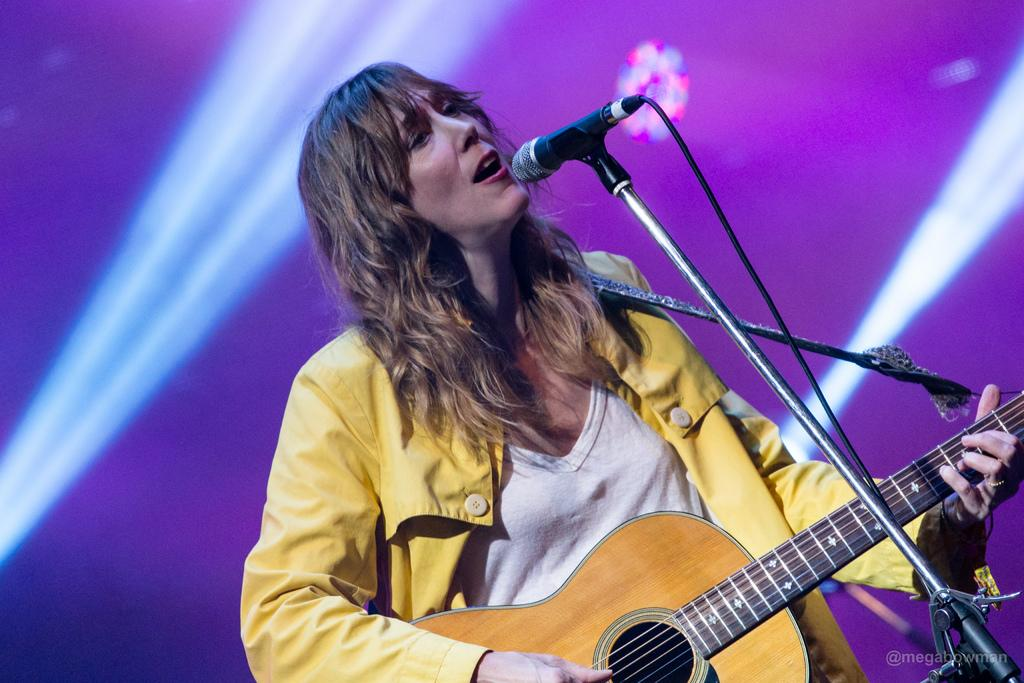Who is in the image? There is a person in the image. What is the person wearing? The person is wearing a yellow dress. What is the person doing in the image? The person is playing a guitar. What object is in front of the person? There is a microphone in front of the person. What type of protest is the person participating in, as depicted in the image? There is no protest present in the image; it features a person playing a guitar with a microphone in front of them. What game is the person playing in the image? There is no game being played in the image; the person is playing a guitar. 